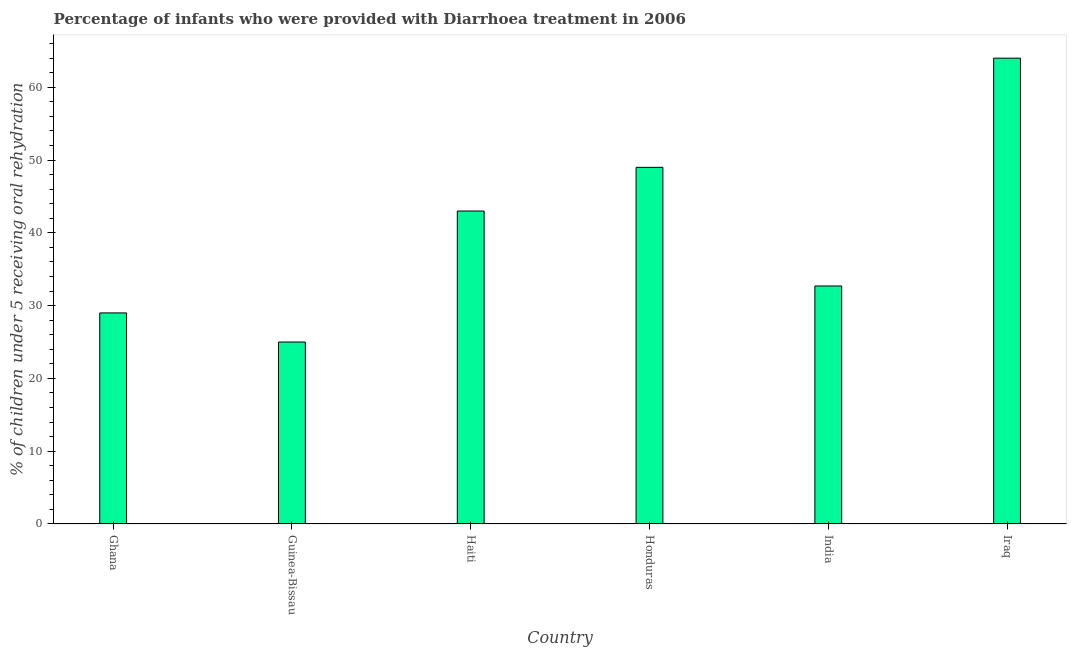What is the title of the graph?
Your response must be concise. Percentage of infants who were provided with Diarrhoea treatment in 2006. What is the label or title of the Y-axis?
Offer a very short reply. % of children under 5 receiving oral rehydration. Across all countries, what is the maximum percentage of children who were provided with treatment diarrhoea?
Make the answer very short. 64. In which country was the percentage of children who were provided with treatment diarrhoea maximum?
Provide a succinct answer. Iraq. In which country was the percentage of children who were provided with treatment diarrhoea minimum?
Provide a succinct answer. Guinea-Bissau. What is the sum of the percentage of children who were provided with treatment diarrhoea?
Offer a terse response. 242.7. What is the average percentage of children who were provided with treatment diarrhoea per country?
Your answer should be compact. 40.45. What is the median percentage of children who were provided with treatment diarrhoea?
Offer a very short reply. 37.85. What is the ratio of the percentage of children who were provided with treatment diarrhoea in Guinea-Bissau to that in Honduras?
Your response must be concise. 0.51. Is the percentage of children who were provided with treatment diarrhoea in Ghana less than that in Iraq?
Offer a terse response. Yes. What is the difference between the highest and the second highest percentage of children who were provided with treatment diarrhoea?
Your answer should be compact. 15. What is the difference between the highest and the lowest percentage of children who were provided with treatment diarrhoea?
Make the answer very short. 39. How many bars are there?
Offer a terse response. 6. Are all the bars in the graph horizontal?
Keep it short and to the point. No. How many countries are there in the graph?
Your answer should be compact. 6. What is the % of children under 5 receiving oral rehydration of Ghana?
Provide a succinct answer. 29. What is the % of children under 5 receiving oral rehydration of Haiti?
Keep it short and to the point. 43. What is the % of children under 5 receiving oral rehydration in Honduras?
Provide a short and direct response. 49. What is the % of children under 5 receiving oral rehydration of India?
Give a very brief answer. 32.7. What is the % of children under 5 receiving oral rehydration in Iraq?
Offer a very short reply. 64. What is the difference between the % of children under 5 receiving oral rehydration in Ghana and Guinea-Bissau?
Provide a succinct answer. 4. What is the difference between the % of children under 5 receiving oral rehydration in Ghana and Honduras?
Keep it short and to the point. -20. What is the difference between the % of children under 5 receiving oral rehydration in Ghana and Iraq?
Offer a very short reply. -35. What is the difference between the % of children under 5 receiving oral rehydration in Guinea-Bissau and Haiti?
Provide a short and direct response. -18. What is the difference between the % of children under 5 receiving oral rehydration in Guinea-Bissau and Honduras?
Your answer should be very brief. -24. What is the difference between the % of children under 5 receiving oral rehydration in Guinea-Bissau and India?
Provide a succinct answer. -7.7. What is the difference between the % of children under 5 receiving oral rehydration in Guinea-Bissau and Iraq?
Your answer should be very brief. -39. What is the difference between the % of children under 5 receiving oral rehydration in India and Iraq?
Offer a very short reply. -31.3. What is the ratio of the % of children under 5 receiving oral rehydration in Ghana to that in Guinea-Bissau?
Provide a succinct answer. 1.16. What is the ratio of the % of children under 5 receiving oral rehydration in Ghana to that in Haiti?
Your answer should be very brief. 0.67. What is the ratio of the % of children under 5 receiving oral rehydration in Ghana to that in Honduras?
Offer a very short reply. 0.59. What is the ratio of the % of children under 5 receiving oral rehydration in Ghana to that in India?
Keep it short and to the point. 0.89. What is the ratio of the % of children under 5 receiving oral rehydration in Ghana to that in Iraq?
Offer a terse response. 0.45. What is the ratio of the % of children under 5 receiving oral rehydration in Guinea-Bissau to that in Haiti?
Make the answer very short. 0.58. What is the ratio of the % of children under 5 receiving oral rehydration in Guinea-Bissau to that in Honduras?
Give a very brief answer. 0.51. What is the ratio of the % of children under 5 receiving oral rehydration in Guinea-Bissau to that in India?
Your answer should be compact. 0.77. What is the ratio of the % of children under 5 receiving oral rehydration in Guinea-Bissau to that in Iraq?
Your answer should be very brief. 0.39. What is the ratio of the % of children under 5 receiving oral rehydration in Haiti to that in Honduras?
Make the answer very short. 0.88. What is the ratio of the % of children under 5 receiving oral rehydration in Haiti to that in India?
Provide a succinct answer. 1.31. What is the ratio of the % of children under 5 receiving oral rehydration in Haiti to that in Iraq?
Give a very brief answer. 0.67. What is the ratio of the % of children under 5 receiving oral rehydration in Honduras to that in India?
Your response must be concise. 1.5. What is the ratio of the % of children under 5 receiving oral rehydration in Honduras to that in Iraq?
Make the answer very short. 0.77. What is the ratio of the % of children under 5 receiving oral rehydration in India to that in Iraq?
Your answer should be very brief. 0.51. 